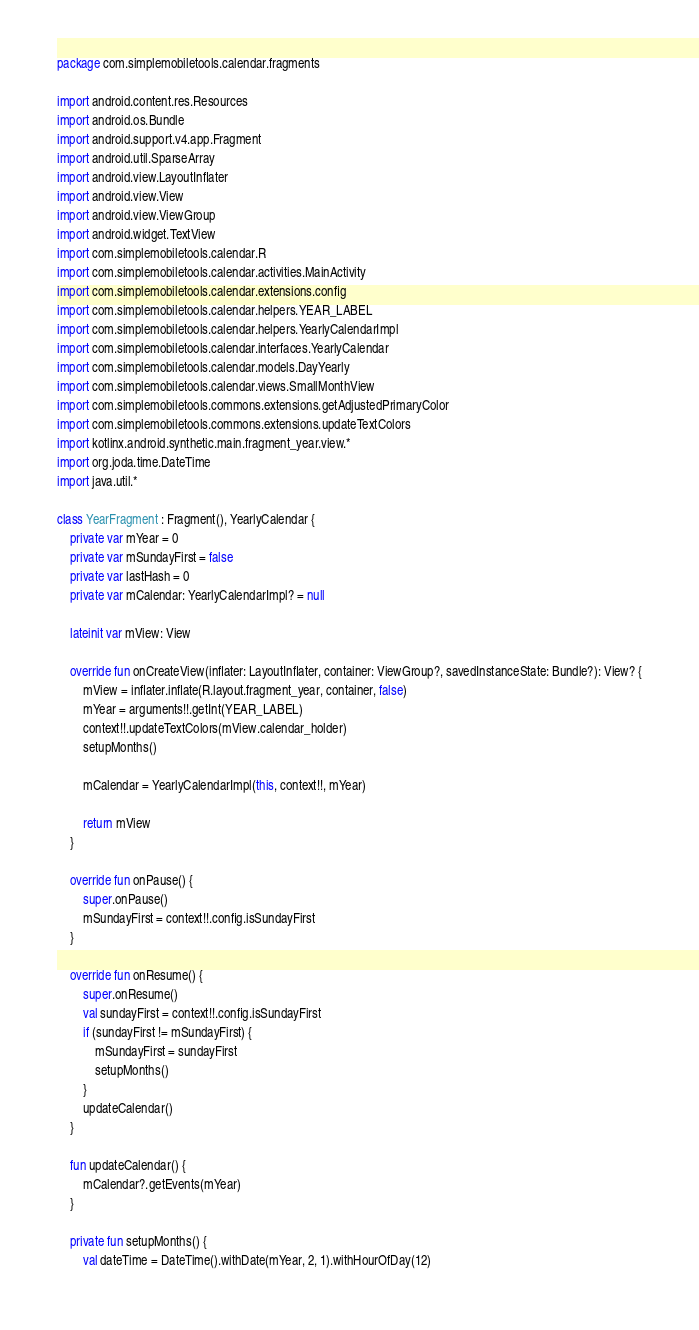Convert code to text. <code><loc_0><loc_0><loc_500><loc_500><_Kotlin_>package com.simplemobiletools.calendar.fragments

import android.content.res.Resources
import android.os.Bundle
import android.support.v4.app.Fragment
import android.util.SparseArray
import android.view.LayoutInflater
import android.view.View
import android.view.ViewGroup
import android.widget.TextView
import com.simplemobiletools.calendar.R
import com.simplemobiletools.calendar.activities.MainActivity
import com.simplemobiletools.calendar.extensions.config
import com.simplemobiletools.calendar.helpers.YEAR_LABEL
import com.simplemobiletools.calendar.helpers.YearlyCalendarImpl
import com.simplemobiletools.calendar.interfaces.YearlyCalendar
import com.simplemobiletools.calendar.models.DayYearly
import com.simplemobiletools.calendar.views.SmallMonthView
import com.simplemobiletools.commons.extensions.getAdjustedPrimaryColor
import com.simplemobiletools.commons.extensions.updateTextColors
import kotlinx.android.synthetic.main.fragment_year.view.*
import org.joda.time.DateTime
import java.util.*

class YearFragment : Fragment(), YearlyCalendar {
    private var mYear = 0
    private var mSundayFirst = false
    private var lastHash = 0
    private var mCalendar: YearlyCalendarImpl? = null

    lateinit var mView: View

    override fun onCreateView(inflater: LayoutInflater, container: ViewGroup?, savedInstanceState: Bundle?): View? {
        mView = inflater.inflate(R.layout.fragment_year, container, false)
        mYear = arguments!!.getInt(YEAR_LABEL)
        context!!.updateTextColors(mView.calendar_holder)
        setupMonths()

        mCalendar = YearlyCalendarImpl(this, context!!, mYear)

        return mView
    }

    override fun onPause() {
        super.onPause()
        mSundayFirst = context!!.config.isSundayFirst
    }

    override fun onResume() {
        super.onResume()
        val sundayFirst = context!!.config.isSundayFirst
        if (sundayFirst != mSundayFirst) {
            mSundayFirst = sundayFirst
            setupMonths()
        }
        updateCalendar()
    }

    fun updateCalendar() {
        mCalendar?.getEvents(mYear)
    }

    private fun setupMonths() {
        val dateTime = DateTime().withDate(mYear, 2, 1).withHourOfDay(12)</code> 